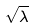Convert formula to latex. <formula><loc_0><loc_0><loc_500><loc_500>\sqrt { \lambda }</formula> 